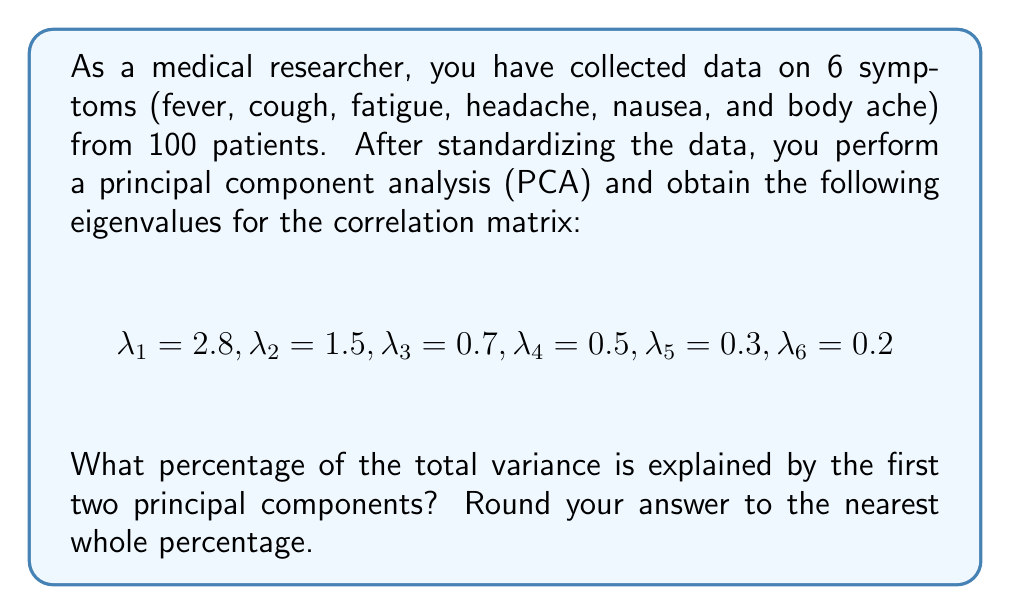Could you help me with this problem? To solve this problem, we'll follow these steps:

1. Calculate the total variance:
   The total variance is the sum of all eigenvalues.
   $$\text{Total Variance} = \sum_{i=1}^6 \lambda_i = 2.8 + 1.5 + 0.7 + 0.5 + 0.3 + 0.2 = 6$$

2. Calculate the variance explained by the first two principal components:
   $$\text{Variance Explained} = \lambda_1 + \lambda_2 = 2.8 + 1.5 = 4.3$$

3. Calculate the percentage of variance explained:
   $$\text{Percentage} = \frac{\text{Variance Explained}}{\text{Total Variance}} \times 100\%$$
   $$= \frac{4.3}{6} \times 100\% \approx 71.67\%$$

4. Round to the nearest whole percentage:
   71.67% rounds to 72%

Therefore, the first two principal components explain approximately 72% of the total variance in the dataset.
Answer: 72% 